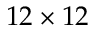<formula> <loc_0><loc_0><loc_500><loc_500>1 2 \times 1 2</formula> 